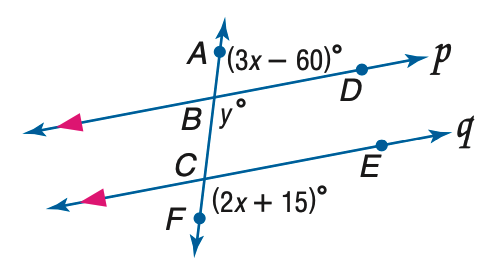Answer the mathemtical geometry problem and directly provide the correct option letter.
Question: Refer to the figure at the right. Find the value of x if p \parallel q.
Choices: A: 27 B: 45 C: 60 D: 75 B 